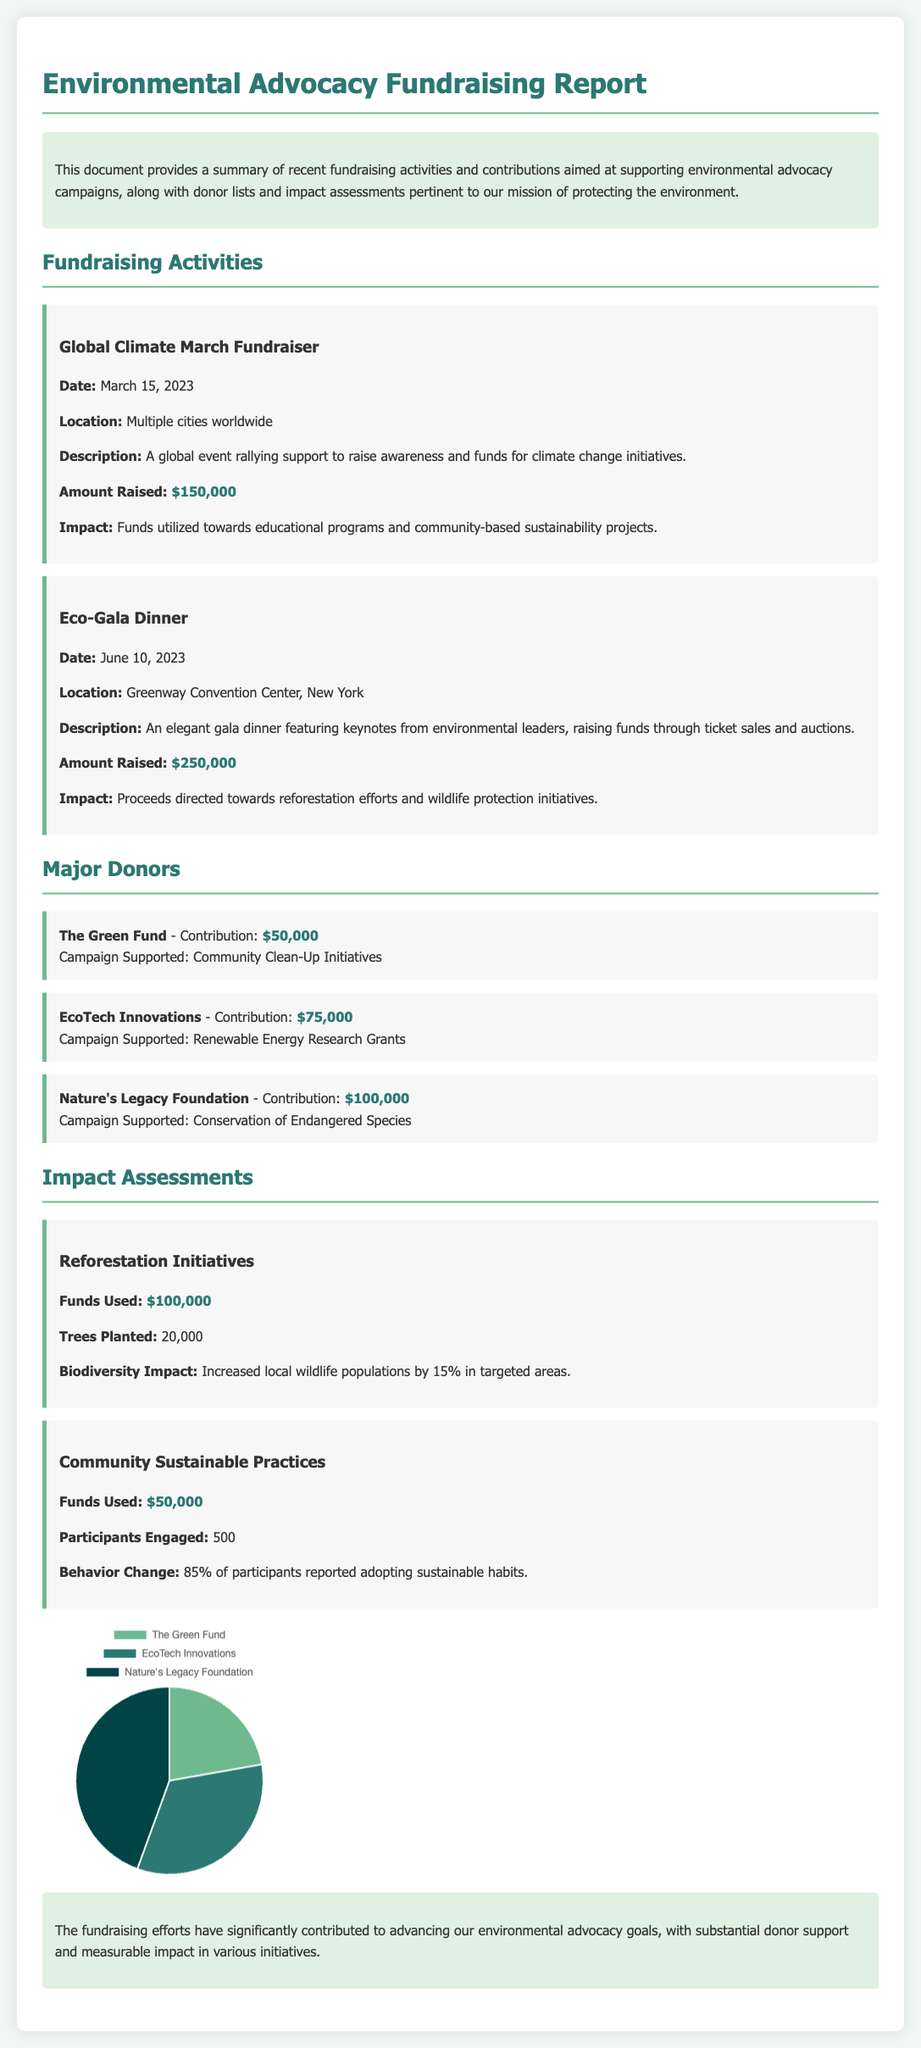What was the amount raised during the Global Climate March Fundraiser? The document states that the amount raised during the Global Climate March Fundraiser was $150,000.
Answer: $150,000 What was the date of the Eco-Gala Dinner? The date of the Eco-Gala Dinner is listed in the document as June 10, 2023.
Answer: June 10, 2023 How many trees were planted through the Reforestation Initiatives? According to the impact assessment, the number of trees planted is mentioned as 20,000.
Answer: 20,000 Which donor contributed the highest amount? The document specifies that Nature's Legacy Foundation contributed the highest amount of $100,000.
Answer: Nature's Legacy Foundation What percentage of participants reported adopting sustainable habits in Community Sustainable Practices? The document states that 85% of participants reported adopting sustainable habits.
Answer: 85% What was the total amount raised from the Eco-Gala Dinner? The total amount raised from the Eco-Gala Dinner is indicated in the document as $250,000.
Answer: $250,000 What campaign did EcoTech Innovations support? The document mentions that EcoTech Innovations supported the Renewable Energy Research Grants campaign.
Answer: Renewable Energy Research Grants How many participants were engaged in Community Sustainable Practices? The number of participants engaged in Community Sustainable Practices is provided as 500.
Answer: 500 What color represents The Green Fund in the donation distribution chart? The document specifies that The Green Fund is represented by the color #6fb98f in the chart.
Answer: #6fb98f 